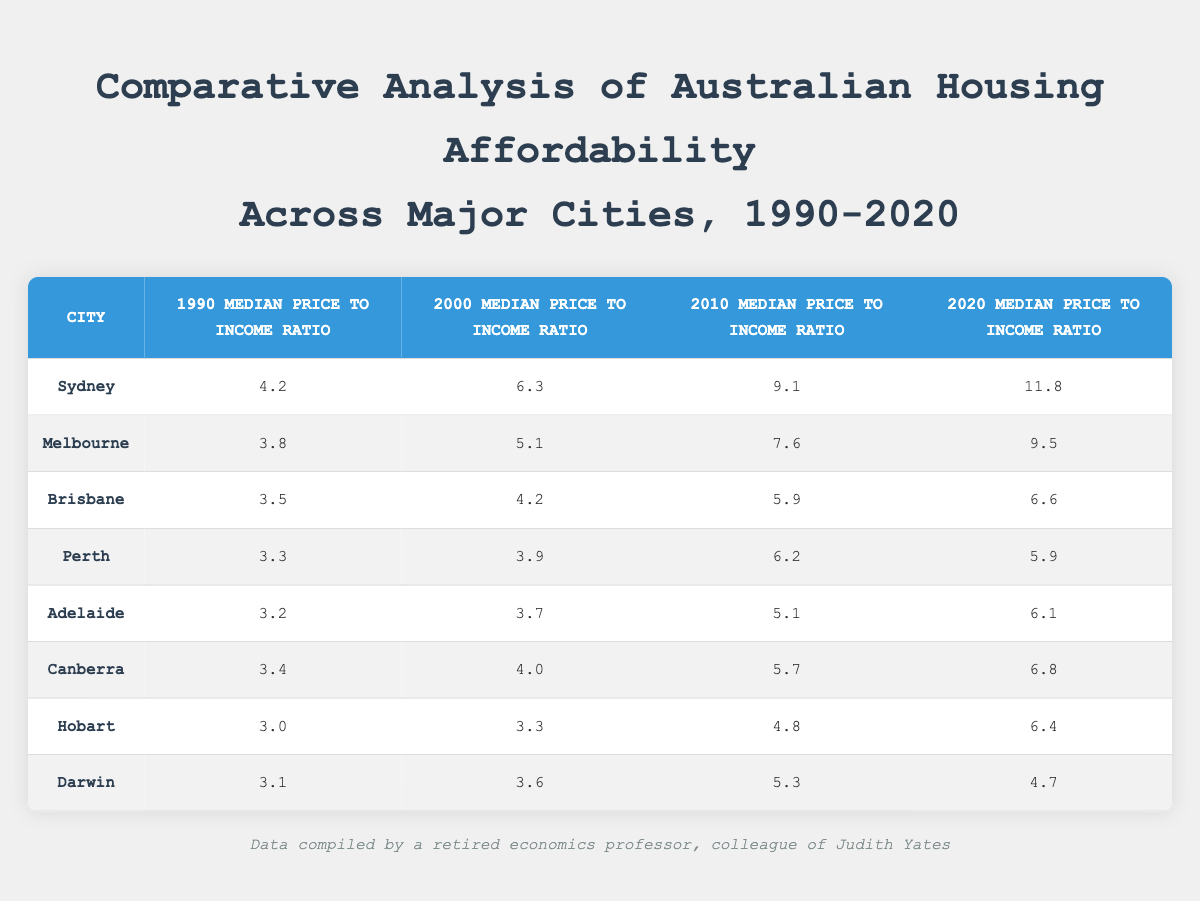What was the median price to income ratio for Brisbane in 2010? According to the table, the value under the "2010 Median Price to Income Ratio" column for Brisbane is 5.9.
Answer: 5.9 Which city had the highest median price to income ratio in 2020? Checking the values in the "2020 Median Price to Income Ratio" column, Sydney has the highest value at 11.8.
Answer: Sydney What is the difference between the median price to income ratios of Adelaide in 1990 and 2020? The ratio for Adelaide in 1990 is 3.2, and in 2020 it is 6.1. The difference is calculated as 6.1 - 3.2 = 2.9.
Answer: 2.9 Did Hobart's median price to income ratio increase from 1990 to 2020? The value for Hobart increased from 3.0 in 1990 to 6.4 in 2020, confirming that the ratio did increase over that period.
Answer: Yes What is the average median price to income ratio for Melbourne from 1990 to 2020? The values for Melbourne are 3.8, 5.1, 7.6, and 9.5. Adding these gives 3.8 + 5.1 + 7.6 + 9.5 = 25. The average is then 25 divided by 4, which is 6.25.
Answer: 6.25 Which city showed the most consistent affordability in terms of median price to income ratios between 1990 and 2020? By examining the data, Perth's values are relatively stable: 3.3, 3.9, 6.2, and 5.9, with smaller fluctuations compared to others like Sydney or Melbourne.
Answer: Perth Was the increase in the median price to income ratio for Canberra from 2010 to 2020 greater than the increase from 2000 to 2010? The increase from 2010 to 2020 is calculated as 6.8 - 5.7 = 1.1, while from 2000 to 2010 it is 5.7 - 4.0 = 1.7. Since 1.1 is less than 1.7, the statement is false.
Answer: No What percentage increase did the median price to income ratio for Sydney experience from 1990 to 2020? Sydney's ratio increased from 4.2 in 1990 to 11.8 in 2020. The change is 11.8 - 4.2 = 7.6. To find the percentage increase: (7.6 / 4.2) * 100 = 180.95%.
Answer: 180.95% 